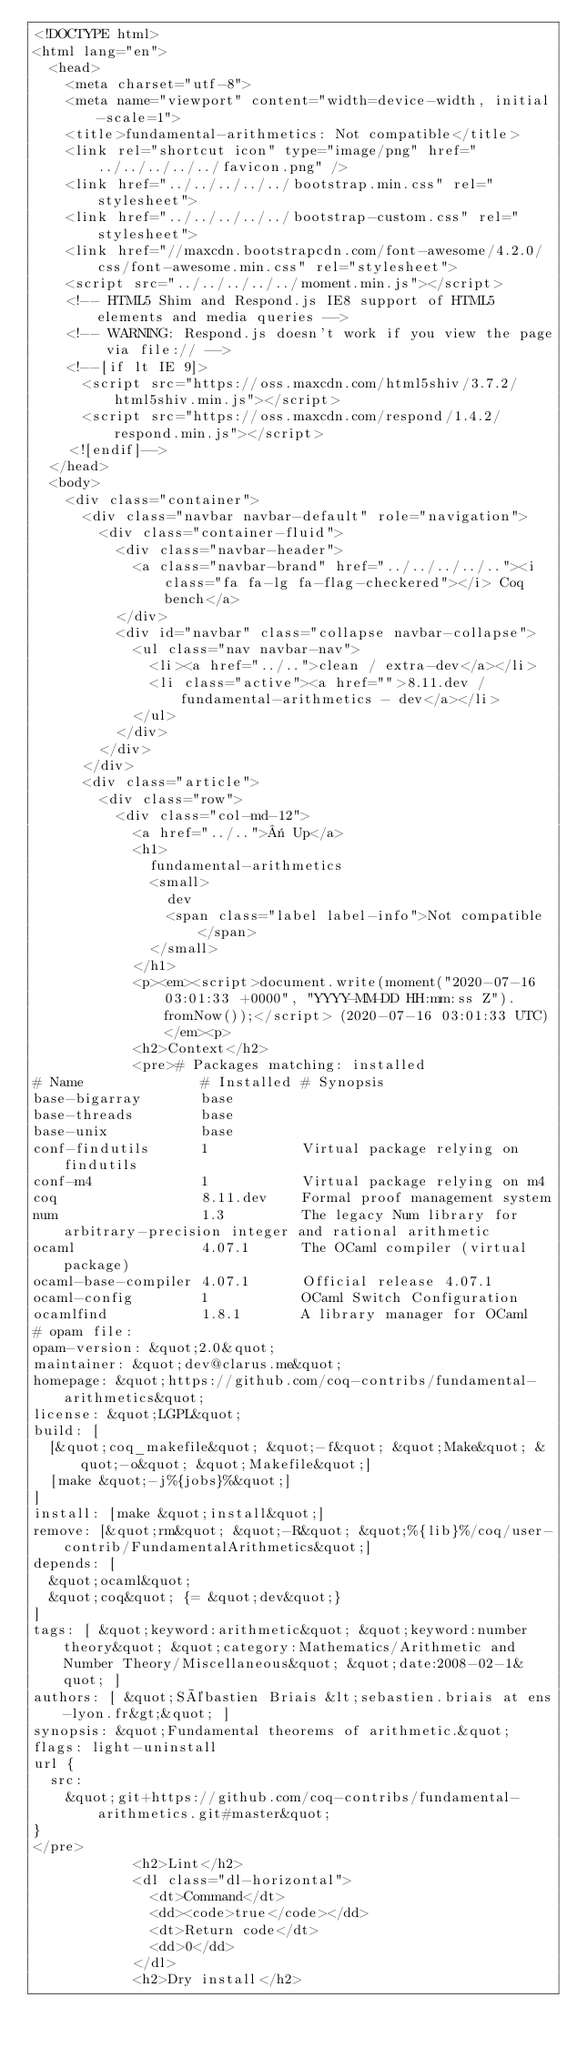<code> <loc_0><loc_0><loc_500><loc_500><_HTML_><!DOCTYPE html>
<html lang="en">
  <head>
    <meta charset="utf-8">
    <meta name="viewport" content="width=device-width, initial-scale=1">
    <title>fundamental-arithmetics: Not compatible</title>
    <link rel="shortcut icon" type="image/png" href="../../../../../favicon.png" />
    <link href="../../../../../bootstrap.min.css" rel="stylesheet">
    <link href="../../../../../bootstrap-custom.css" rel="stylesheet">
    <link href="//maxcdn.bootstrapcdn.com/font-awesome/4.2.0/css/font-awesome.min.css" rel="stylesheet">
    <script src="../../../../../moment.min.js"></script>
    <!-- HTML5 Shim and Respond.js IE8 support of HTML5 elements and media queries -->
    <!-- WARNING: Respond.js doesn't work if you view the page via file:// -->
    <!--[if lt IE 9]>
      <script src="https://oss.maxcdn.com/html5shiv/3.7.2/html5shiv.min.js"></script>
      <script src="https://oss.maxcdn.com/respond/1.4.2/respond.min.js"></script>
    <![endif]-->
  </head>
  <body>
    <div class="container">
      <div class="navbar navbar-default" role="navigation">
        <div class="container-fluid">
          <div class="navbar-header">
            <a class="navbar-brand" href="../../../../.."><i class="fa fa-lg fa-flag-checkered"></i> Coq bench</a>
          </div>
          <div id="navbar" class="collapse navbar-collapse">
            <ul class="nav navbar-nav">
              <li><a href="../..">clean / extra-dev</a></li>
              <li class="active"><a href="">8.11.dev / fundamental-arithmetics - dev</a></li>
            </ul>
          </div>
        </div>
      </div>
      <div class="article">
        <div class="row">
          <div class="col-md-12">
            <a href="../..">« Up</a>
            <h1>
              fundamental-arithmetics
              <small>
                dev
                <span class="label label-info">Not compatible</span>
              </small>
            </h1>
            <p><em><script>document.write(moment("2020-07-16 03:01:33 +0000", "YYYY-MM-DD HH:mm:ss Z").fromNow());</script> (2020-07-16 03:01:33 UTC)</em><p>
            <h2>Context</h2>
            <pre># Packages matching: installed
# Name              # Installed # Synopsis
base-bigarray       base
base-threads        base
base-unix           base
conf-findutils      1           Virtual package relying on findutils
conf-m4             1           Virtual package relying on m4
coq                 8.11.dev    Formal proof management system
num                 1.3         The legacy Num library for arbitrary-precision integer and rational arithmetic
ocaml               4.07.1      The OCaml compiler (virtual package)
ocaml-base-compiler 4.07.1      Official release 4.07.1
ocaml-config        1           OCaml Switch Configuration
ocamlfind           1.8.1       A library manager for OCaml
# opam file:
opam-version: &quot;2.0&quot;
maintainer: &quot;dev@clarus.me&quot;
homepage: &quot;https://github.com/coq-contribs/fundamental-arithmetics&quot;
license: &quot;LGPL&quot;
build: [
  [&quot;coq_makefile&quot; &quot;-f&quot; &quot;Make&quot; &quot;-o&quot; &quot;Makefile&quot;]
  [make &quot;-j%{jobs}%&quot;]
]
install: [make &quot;install&quot;]
remove: [&quot;rm&quot; &quot;-R&quot; &quot;%{lib}%/coq/user-contrib/FundamentalArithmetics&quot;]
depends: [
  &quot;ocaml&quot;
  &quot;coq&quot; {= &quot;dev&quot;}
]
tags: [ &quot;keyword:arithmetic&quot; &quot;keyword:number theory&quot; &quot;category:Mathematics/Arithmetic and Number Theory/Miscellaneous&quot; &quot;date:2008-02-1&quot; ]
authors: [ &quot;Sébastien Briais &lt;sebastien.briais at ens-lyon.fr&gt;&quot; ]
synopsis: &quot;Fundamental theorems of arithmetic.&quot;
flags: light-uninstall
url {
  src:
    &quot;git+https://github.com/coq-contribs/fundamental-arithmetics.git#master&quot;
}
</pre>
            <h2>Lint</h2>
            <dl class="dl-horizontal">
              <dt>Command</dt>
              <dd><code>true</code></dd>
              <dt>Return code</dt>
              <dd>0</dd>
            </dl>
            <h2>Dry install</h2></code> 